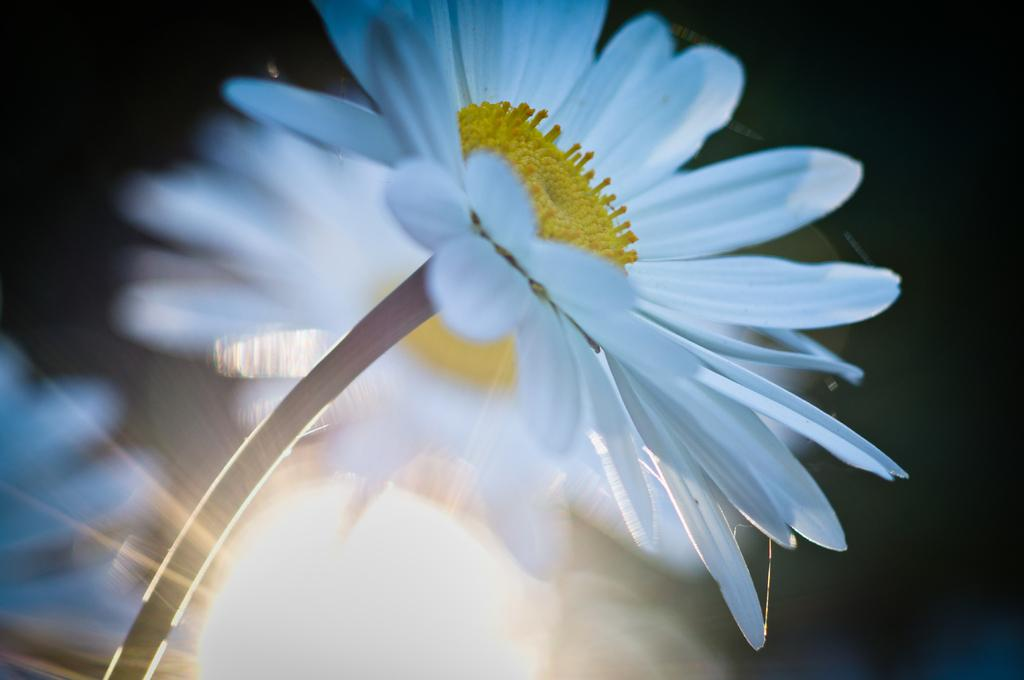What is present in the image? There is a flower in the image. Can you describe the flower in the image? The flower is white in color. Can you tell me how many layers are in the cake in the image? There is no cake present in the image; it features a white flower. What type of owl can be seen perched on the flower in the image? There is no owl present in the image; it features a white flower. 